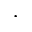<formula> <loc_0><loc_0><loc_500><loc_500>\cdot</formula> 